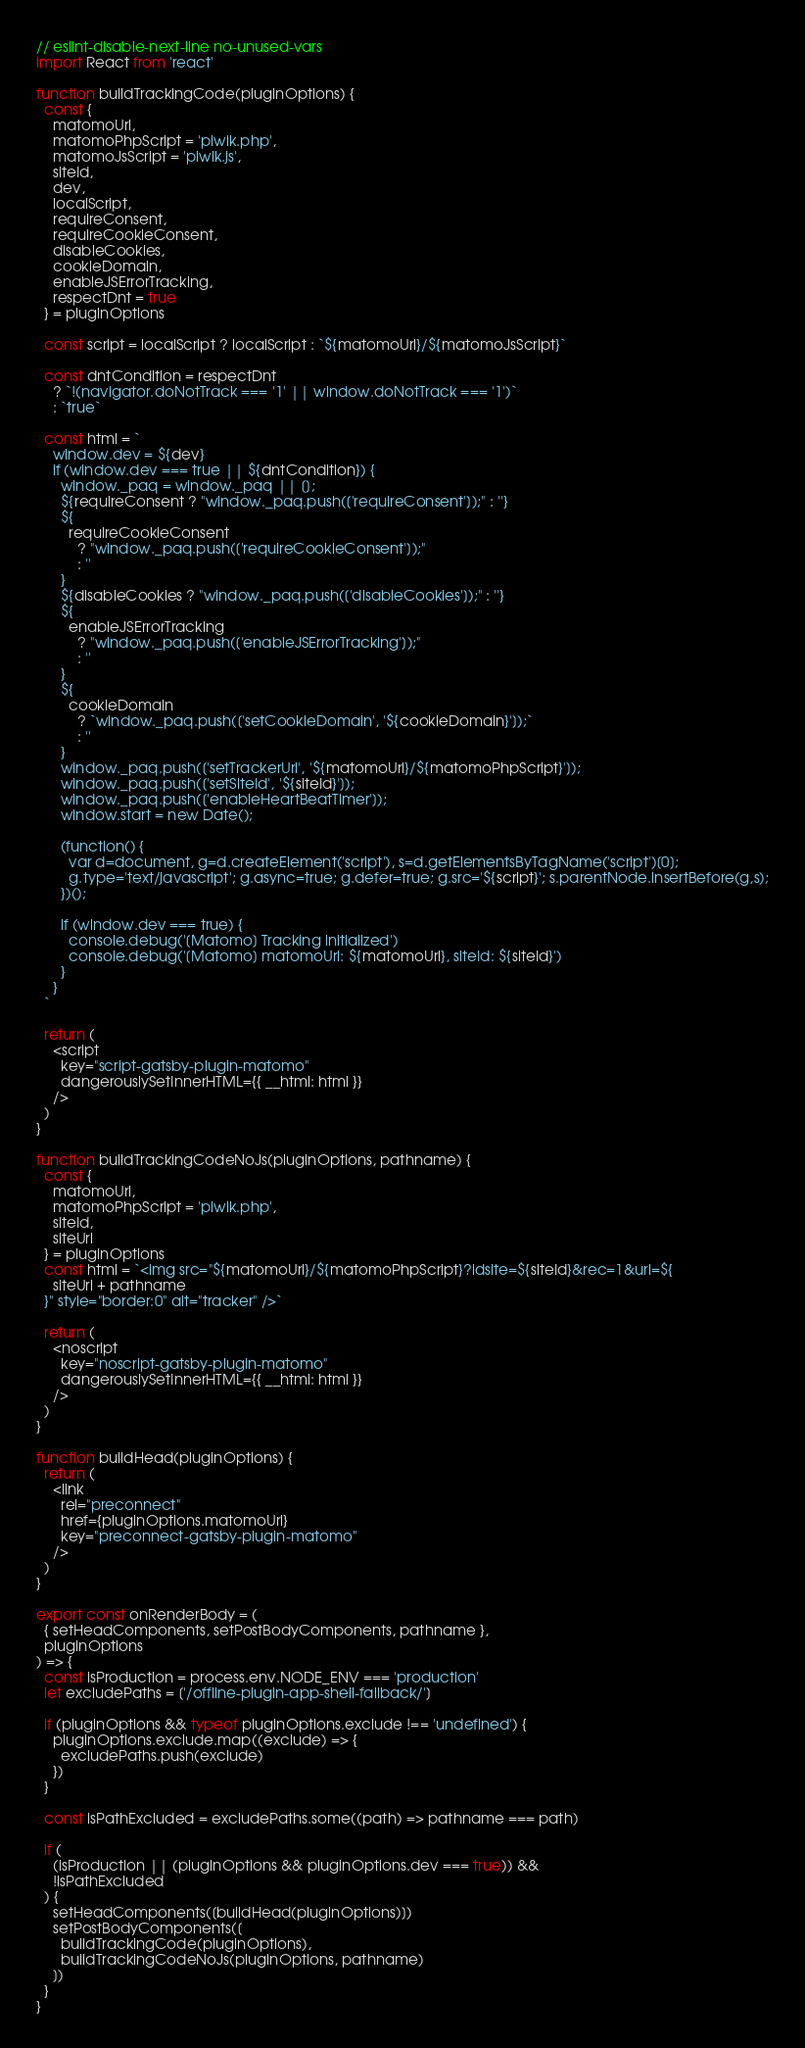Convert code to text. <code><loc_0><loc_0><loc_500><loc_500><_JavaScript_>// eslint-disable-next-line no-unused-vars
import React from 'react'

function buildTrackingCode(pluginOptions) {
  const {
    matomoUrl,
    matomoPhpScript = 'piwik.php',
    matomoJsScript = 'piwik.js',
    siteId,
    dev,
    localScript,
    requireConsent,
    requireCookieConsent,
    disableCookies,
    cookieDomain,
    enableJSErrorTracking,
    respectDnt = true
  } = pluginOptions

  const script = localScript ? localScript : `${matomoUrl}/${matomoJsScript}`

  const dntCondition = respectDnt
    ? `!(navigator.doNotTrack === '1' || window.doNotTrack === '1')`
    : `true`

  const html = `
    window.dev = ${dev}
    if (window.dev === true || ${dntCondition}) {
      window._paq = window._paq || [];
      ${requireConsent ? "window._paq.push(['requireConsent']);" : ''}
      ${
        requireCookieConsent
          ? "window._paq.push(['requireCookieConsent']);"
          : ''
      }
      ${disableCookies ? "window._paq.push(['disableCookies']);" : ''}
      ${
        enableJSErrorTracking
          ? "window._paq.push(['enableJSErrorTracking']);"
          : ''
      }
      ${
        cookieDomain
          ? `window._paq.push(['setCookieDomain', '${cookieDomain}']);`
          : ''
      }
      window._paq.push(['setTrackerUrl', '${matomoUrl}/${matomoPhpScript}']);
      window._paq.push(['setSiteId', '${siteId}']);
      window._paq.push(['enableHeartBeatTimer']);
      window.start = new Date();

      (function() {
        var d=document, g=d.createElement('script'), s=d.getElementsByTagName('script')[0];
        g.type='text/javascript'; g.async=true; g.defer=true; g.src='${script}'; s.parentNode.insertBefore(g,s);
      })();

      if (window.dev === true) {
        console.debug('[Matomo] Tracking initialized')
        console.debug('[Matomo] matomoUrl: ${matomoUrl}, siteId: ${siteId}')
      }
    }
  `

  return (
    <script
      key="script-gatsby-plugin-matomo"
      dangerouslySetInnerHTML={{ __html: html }}
    />
  )
}

function buildTrackingCodeNoJs(pluginOptions, pathname) {
  const {
    matomoUrl,
    matomoPhpScript = 'piwik.php',
    siteId,
    siteUrl
  } = pluginOptions
  const html = `<img src="${matomoUrl}/${matomoPhpScript}?idsite=${siteId}&rec=1&url=${
    siteUrl + pathname
  }" style="border:0" alt="tracker" />`

  return (
    <noscript
      key="noscript-gatsby-plugin-matomo"
      dangerouslySetInnerHTML={{ __html: html }}
    />
  )
}

function buildHead(pluginOptions) {
  return (
    <link
      rel="preconnect"
      href={pluginOptions.matomoUrl}
      key="preconnect-gatsby-plugin-matomo"
    />
  )
}

export const onRenderBody = (
  { setHeadComponents, setPostBodyComponents, pathname },
  pluginOptions
) => {
  const isProduction = process.env.NODE_ENV === 'production'
  let excludePaths = ['/offline-plugin-app-shell-fallback/']

  if (pluginOptions && typeof pluginOptions.exclude !== 'undefined') {
    pluginOptions.exclude.map((exclude) => {
      excludePaths.push(exclude)
    })
  }

  const isPathExcluded = excludePaths.some((path) => pathname === path)

  if (
    (isProduction || (pluginOptions && pluginOptions.dev === true)) &&
    !isPathExcluded
  ) {
    setHeadComponents([buildHead(pluginOptions)])
    setPostBodyComponents([
      buildTrackingCode(pluginOptions),
      buildTrackingCodeNoJs(pluginOptions, pathname)
    ])
  }
}
</code> 